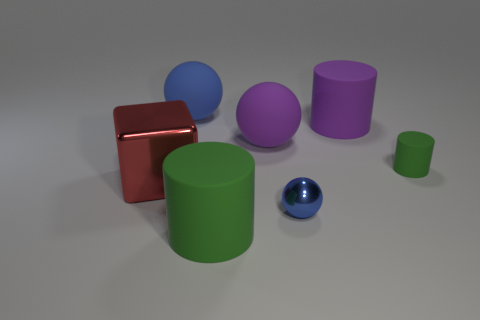Add 3 matte things. How many objects exist? 10 Subtract all cylinders. How many objects are left? 4 Subtract all large red metallic things. Subtract all large green cylinders. How many objects are left? 5 Add 7 cubes. How many cubes are left? 8 Add 4 tiny blue spheres. How many tiny blue spheres exist? 5 Subtract 0 blue blocks. How many objects are left? 7 